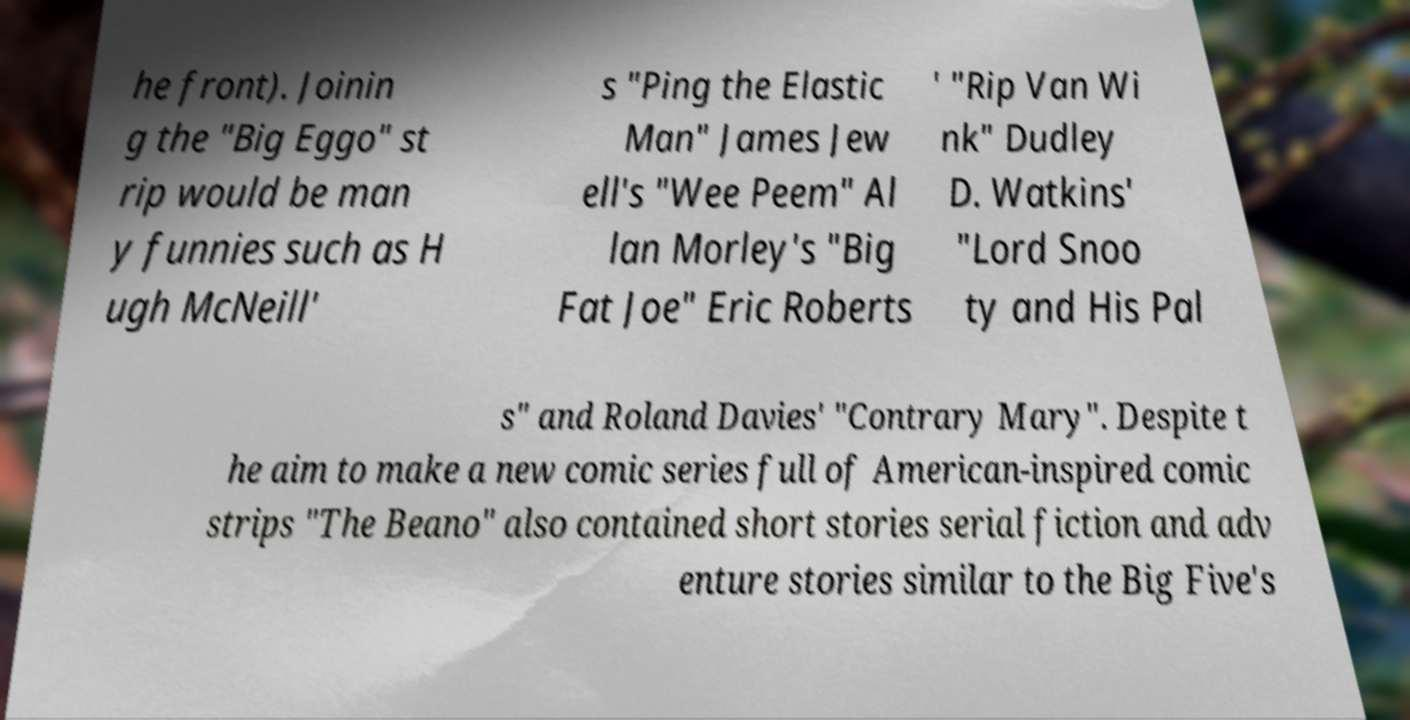Could you assist in decoding the text presented in this image and type it out clearly? he front). Joinin g the "Big Eggo" st rip would be man y funnies such as H ugh McNeill' s "Ping the Elastic Man" James Jew ell's "Wee Peem" Al lan Morley's "Big Fat Joe" Eric Roberts ' "Rip Van Wi nk" Dudley D. Watkins' "Lord Snoo ty and His Pal s" and Roland Davies' "Contrary Mary". Despite t he aim to make a new comic series full of American-inspired comic strips "The Beano" also contained short stories serial fiction and adv enture stories similar to the Big Five's 